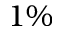Convert formula to latex. <formula><loc_0><loc_0><loc_500><loc_500>1 \%</formula> 